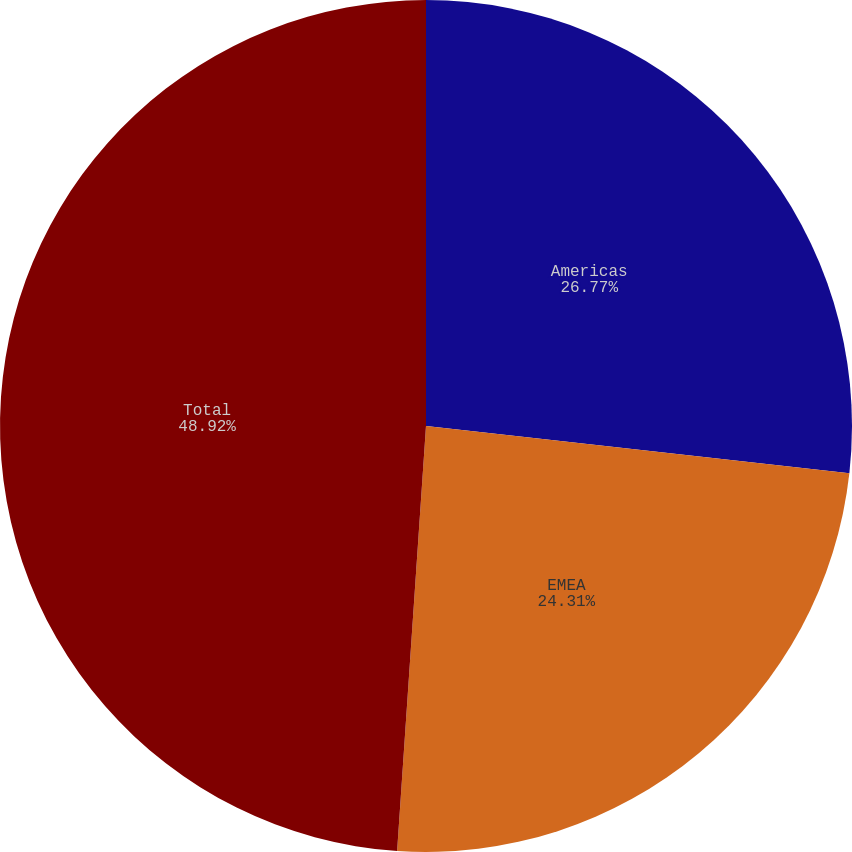Convert chart. <chart><loc_0><loc_0><loc_500><loc_500><pie_chart><fcel>Americas<fcel>EMEA<fcel>Total<nl><fcel>26.77%<fcel>24.31%<fcel>48.92%<nl></chart> 